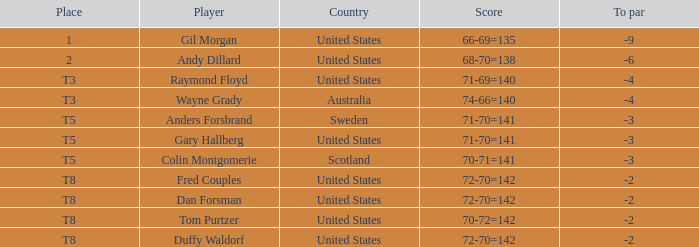What is the T8 Place Player? Fred Couples, Dan Forsman, Tom Purtzer, Duffy Waldorf. I'm looking to parse the entire table for insights. Could you assist me with that? {'header': ['Place', 'Player', 'Country', 'Score', 'To par'], 'rows': [['1', 'Gil Morgan', 'United States', '66-69=135', '-9'], ['2', 'Andy Dillard', 'United States', '68-70=138', '-6'], ['T3', 'Raymond Floyd', 'United States', '71-69=140', '-4'], ['T3', 'Wayne Grady', 'Australia', '74-66=140', '-4'], ['T5', 'Anders Forsbrand', 'Sweden', '71-70=141', '-3'], ['T5', 'Gary Hallberg', 'United States', '71-70=141', '-3'], ['T5', 'Colin Montgomerie', 'Scotland', '70-71=141', '-3'], ['T8', 'Fred Couples', 'United States', '72-70=142', '-2'], ['T8', 'Dan Forsman', 'United States', '72-70=142', '-2'], ['T8', 'Tom Purtzer', 'United States', '70-72=142', '-2'], ['T8', 'Duffy Waldorf', 'United States', '72-70=142', '-2']]} 